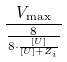Convert formula to latex. <formula><loc_0><loc_0><loc_500><loc_500>\frac { V _ { \max } } { \frac { 8 } { 8 \cdot \frac { [ U ] } { [ U ] + Z _ { i } } } }</formula> 